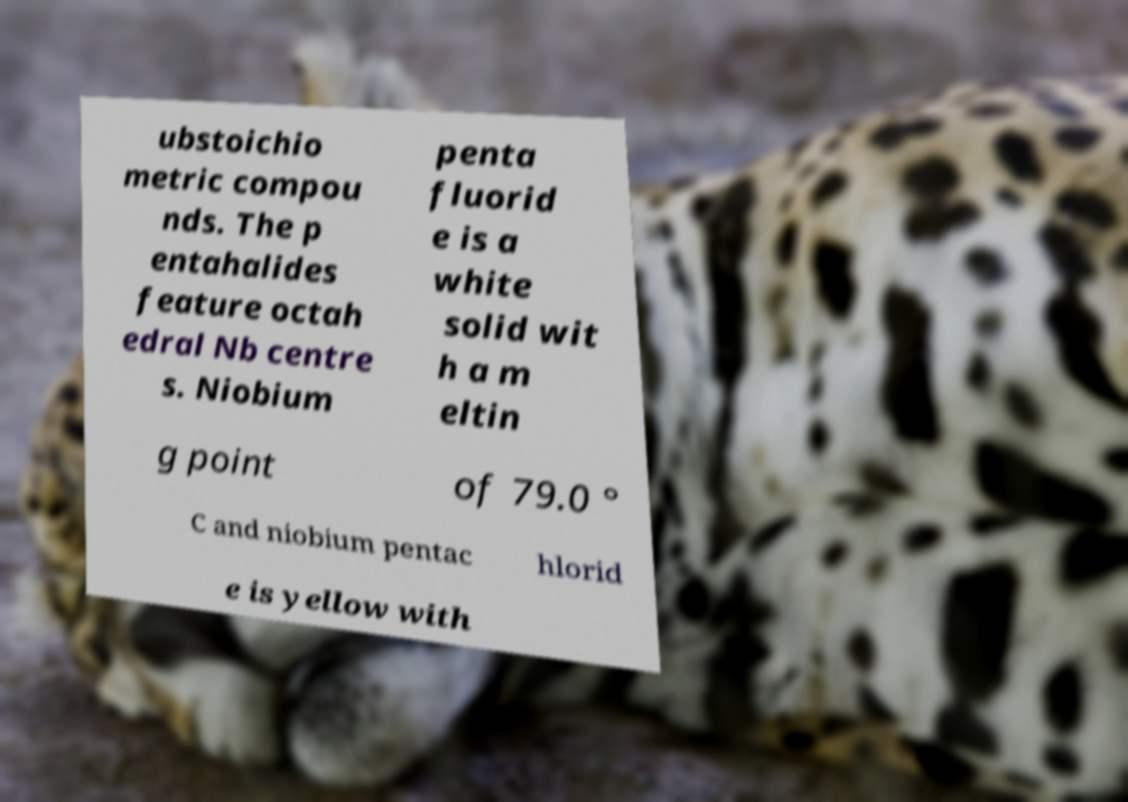Could you extract and type out the text from this image? ubstoichio metric compou nds. The p entahalides feature octah edral Nb centre s. Niobium penta fluorid e is a white solid wit h a m eltin g point of 79.0 ° C and niobium pentac hlorid e is yellow with 